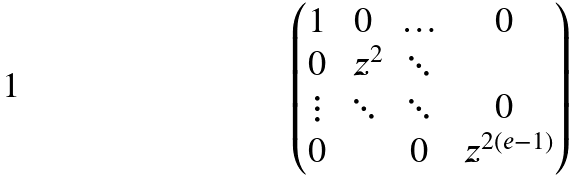Convert formula to latex. <formula><loc_0><loc_0><loc_500><loc_500>\begin{pmatrix} 1 & 0 & \hdots & 0 \\ 0 & \ z ^ { 2 } & \ddots & \\ \vdots & \ddots & \ddots & 0 \\ 0 & & 0 & \ z ^ { 2 ( e - 1 ) } \end{pmatrix}</formula> 